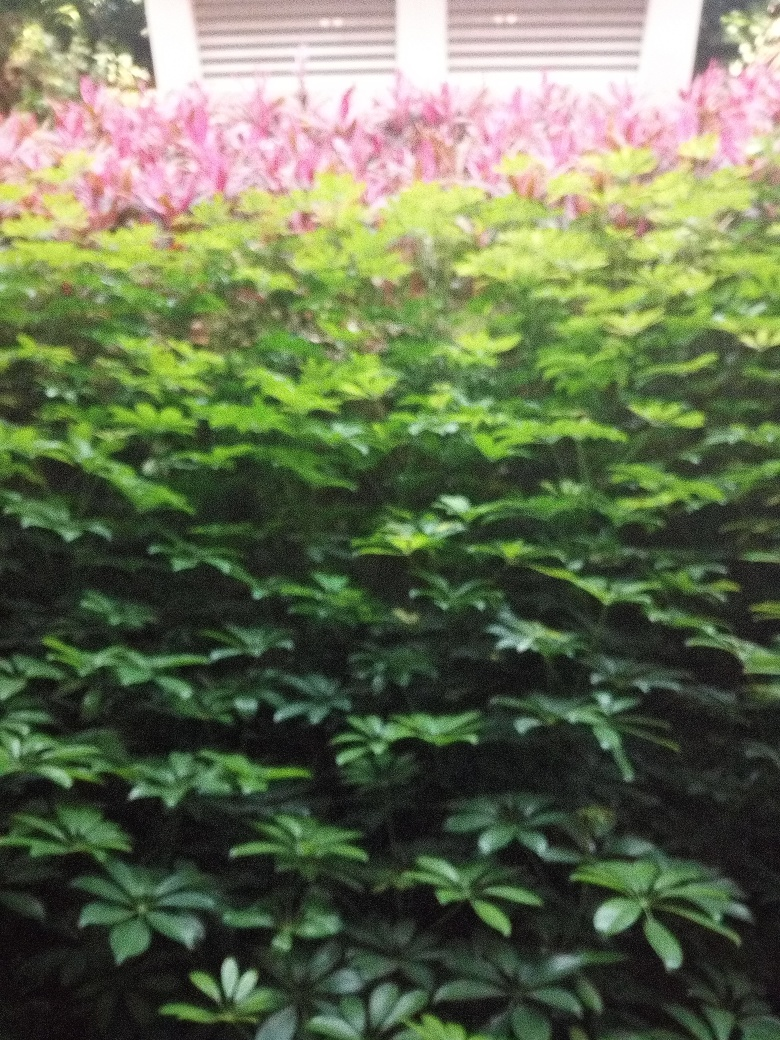Does the image give any clues about the location where it was taken? The image appears to show a landscaped garden, possibly situated within a temperate climate zone given the lush greenery. The presence of a building in the background with closed shutters suggests an urban or suburban setting. 